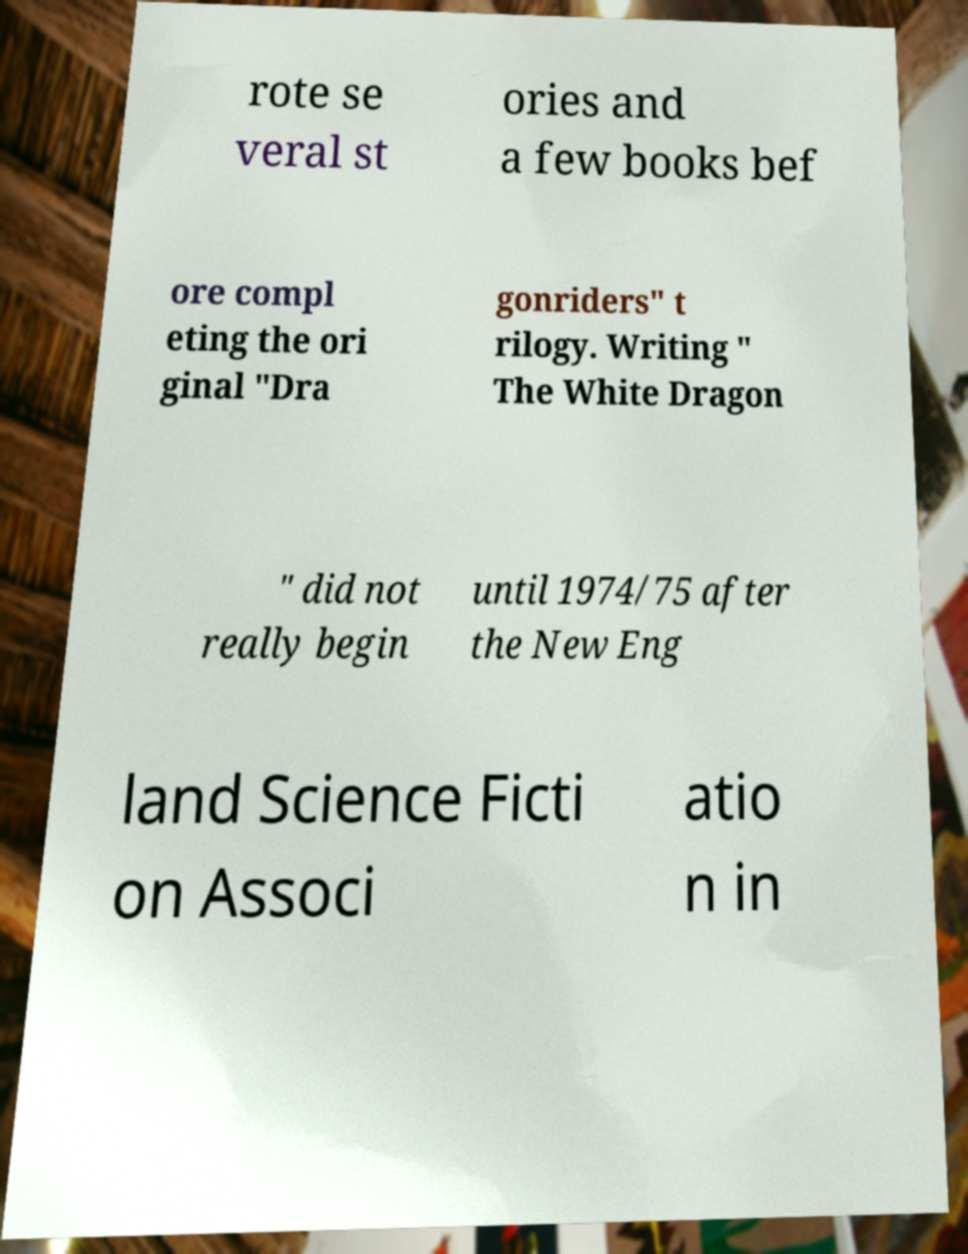Could you assist in decoding the text presented in this image and type it out clearly? rote se veral st ories and a few books bef ore compl eting the ori ginal "Dra gonriders" t rilogy. Writing " The White Dragon " did not really begin until 1974/75 after the New Eng land Science Ficti on Associ atio n in 